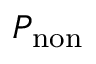<formula> <loc_0><loc_0><loc_500><loc_500>P _ { n o n }</formula> 